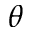<formula> <loc_0><loc_0><loc_500><loc_500>\theta</formula> 